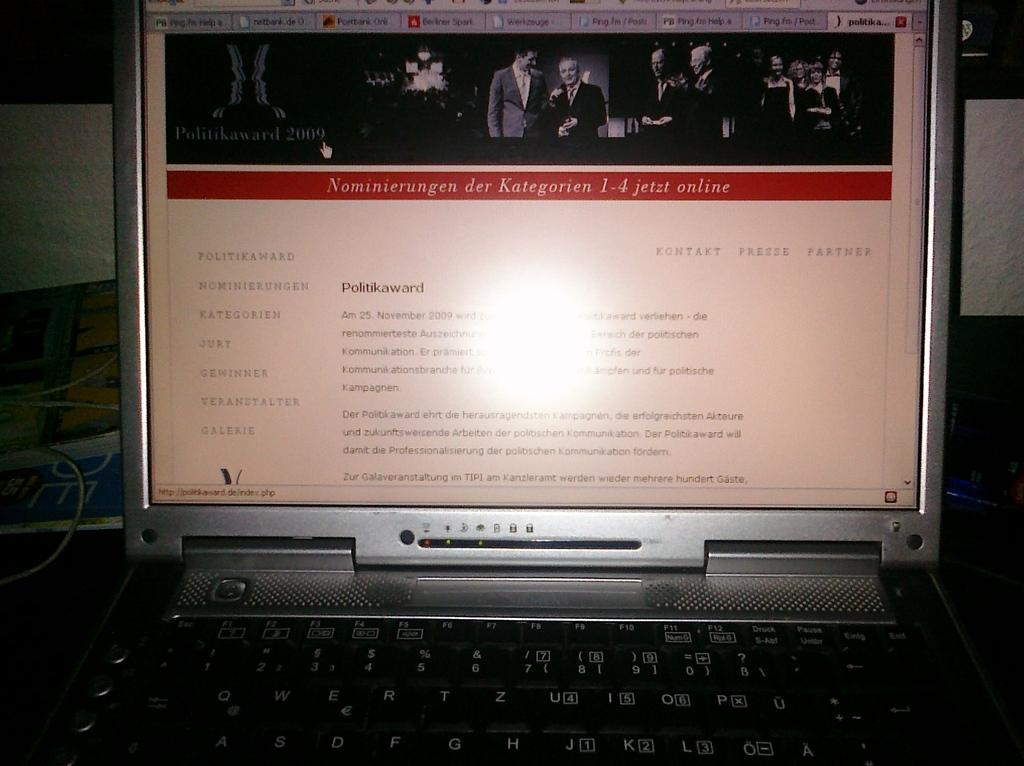<image>
Render a clear and concise summary of the photo. a laptop that says Politikaward on the front of it 